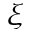<formula> <loc_0><loc_0><loc_500><loc_500>\xi</formula> 